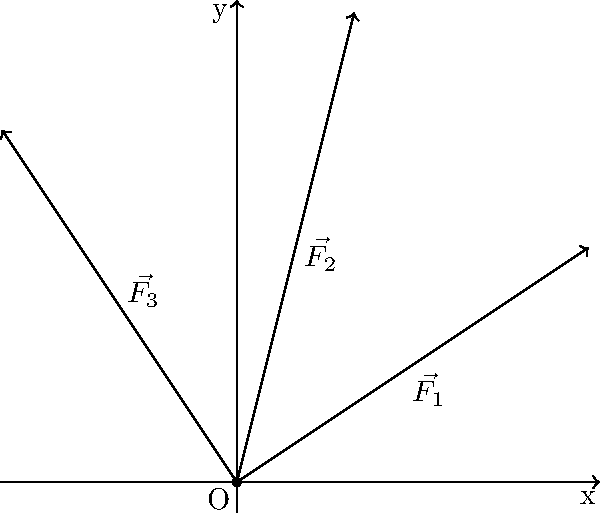During the analysis of an ancient fossil sample, three forces are applied simultaneously to measure its resistance. The forces are represented as vectors in a 2D plane: $\vec{F_1} = 3\hat{i} + 2\hat{j}$, $\vec{F_2} = \hat{i} + 4\hat{j}$, and $\vec{F_3} = -2\hat{i} + 3\hat{j}$, where $\hat{i}$ and $\hat{j}$ are unit vectors in the x and y directions, respectively. Calculate the magnitude of the resultant force vector acting on the fossil sample. To find the magnitude of the resultant force vector, we'll follow these steps:

1) First, we need to find the resultant vector by adding all the force vectors:
   $\vec{R} = \vec{F_1} + \vec{F_2} + \vec{F_3}$

2) Let's add the x-components and y-components separately:
   x-component: $3 + 1 + (-2) = 2$
   y-component: $2 + 4 + 3 = 9$

3) So, the resultant vector is:
   $\vec{R} = 2\hat{i} + 9\hat{j}$

4) To find the magnitude of this vector, we use the Pythagorean theorem:
   $|\vec{R}| = \sqrt{x^2 + y^2}$

5) Substituting our values:
   $|\vec{R}| = \sqrt{2^2 + 9^2}$

6) Simplify:
   $|\vec{R}| = \sqrt{4 + 81} = \sqrt{85}$

7) The final magnitude is $\sqrt{85}$ units.
Answer: $\sqrt{85}$ units 